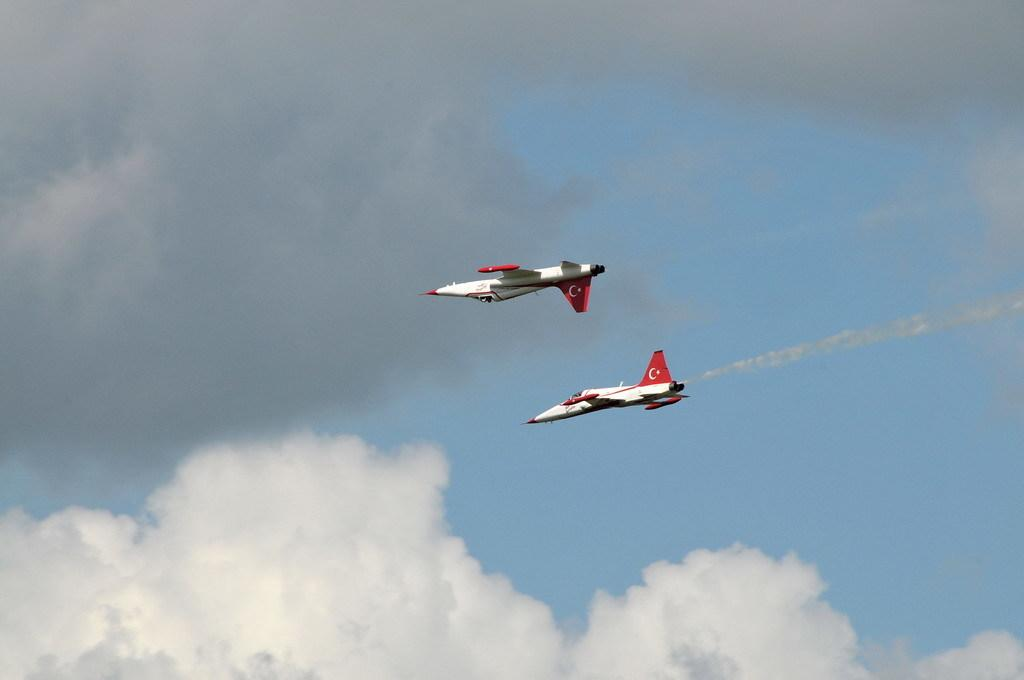What is the main subject of the image? The main subject of the image is two aircrafts. What are the aircrafts doing in the image? The aircrafts are flying in the sky. Can you describe any additional features of the aircrafts? Yes, the aircrafts are emitting smoke. What can be seen at the bottom of the image? There are clouds at the bottom of the image. Reasoning: Let's think step by following the guidelines to produce the conversation. We start by identifying the main subject of the image, which is the two aircrafts. Then, we describe their actions, which are flying in the sky. Next, we mention any additional features, such as the smoke emitted by the aircrafts. Finally, we describe the background of the image, which includes clouds at the bottom. Absurd Question/Answer: What type of riddle is being solved on the desk in the image? There is no desk or riddle present in the image; it features two aircrafts flying in the sky and emitting smoke. What is the person in the image doing? The person is sitting on a bench and reading a book. What can be seen behind the bench? There is a tree behind the bench. What is visible in the background of the image? The sky is visible in the background. Reasoning: Let's think step by step in order to produce the conversation. We start by identifying the main subject of the image, which is the person sitting on the bench. Then, we describe their action, which is reading a book. Next, we mention the object behind the bench, which is a tree. Finally, we describe the background of the image, which includes the sky. Absurd Question/Answer: Can you tell me how many parrots are sitting on the bicycle in the image? There are no parrots or bicycles present in the image; it features a person sitting on a bench and reading a book, with a tree behind the bench and the sky visible in the background. Reasoning: Let's think step by step in order to produce 